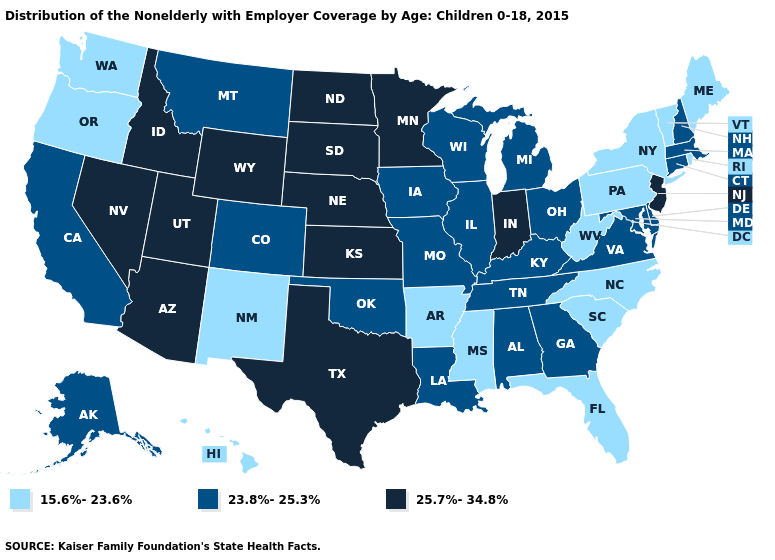Among the states that border Pennsylvania , which have the lowest value?
Short answer required. New York, West Virginia. Name the states that have a value in the range 23.8%-25.3%?
Be succinct. Alabama, Alaska, California, Colorado, Connecticut, Delaware, Georgia, Illinois, Iowa, Kentucky, Louisiana, Maryland, Massachusetts, Michigan, Missouri, Montana, New Hampshire, Ohio, Oklahoma, Tennessee, Virginia, Wisconsin. Name the states that have a value in the range 15.6%-23.6%?
Short answer required. Arkansas, Florida, Hawaii, Maine, Mississippi, New Mexico, New York, North Carolina, Oregon, Pennsylvania, Rhode Island, South Carolina, Vermont, Washington, West Virginia. What is the lowest value in states that border Arizona?
Write a very short answer. 15.6%-23.6%. What is the value of Oregon?
Write a very short answer. 15.6%-23.6%. Does Pennsylvania have the highest value in the Northeast?
Keep it brief. No. Does Missouri have the same value as Vermont?
Short answer required. No. Among the states that border Michigan , which have the lowest value?
Keep it brief. Ohio, Wisconsin. Among the states that border Arkansas , does Texas have the lowest value?
Short answer required. No. Does Hawaii have the lowest value in the USA?
Be succinct. Yes. What is the value of Pennsylvania?
Answer briefly. 15.6%-23.6%. Among the states that border Virginia , does West Virginia have the lowest value?
Give a very brief answer. Yes. Does Wyoming have the same value as Minnesota?
Keep it brief. Yes. What is the value of Arkansas?
Answer briefly. 15.6%-23.6%. 